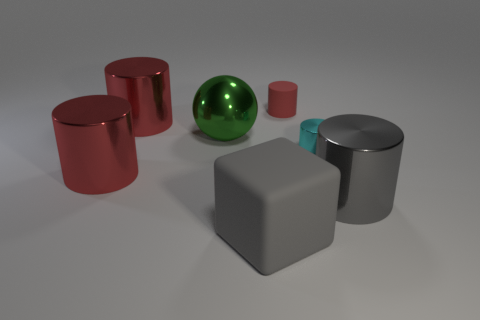There is a thing that is the same color as the big cube; what is its size?
Your answer should be compact. Large. There is a gray object on the left side of the large gray cylinder; how big is it?
Provide a short and direct response. Large. What number of metal objects are the same color as the block?
Offer a terse response. 1. How many blocks are either large metallic objects or gray rubber things?
Offer a very short reply. 1. What is the shape of the large thing that is both on the right side of the green sphere and left of the tiny metal cylinder?
Provide a succinct answer. Cube. Is there a cyan metal object of the same size as the matte cylinder?
Provide a short and direct response. Yes. What number of objects are big metal objects that are on the right side of the small cyan metal thing or small cyan shiny cylinders?
Provide a succinct answer. 2. Is the material of the gray cube the same as the large gray object that is behind the big gray rubber block?
Offer a very short reply. No. How many other things are the same shape as the tiny red rubber thing?
Ensure brevity in your answer.  4. How many things are metal objects to the right of the rubber cube or red cylinders in front of the red rubber cylinder?
Provide a short and direct response. 4. 